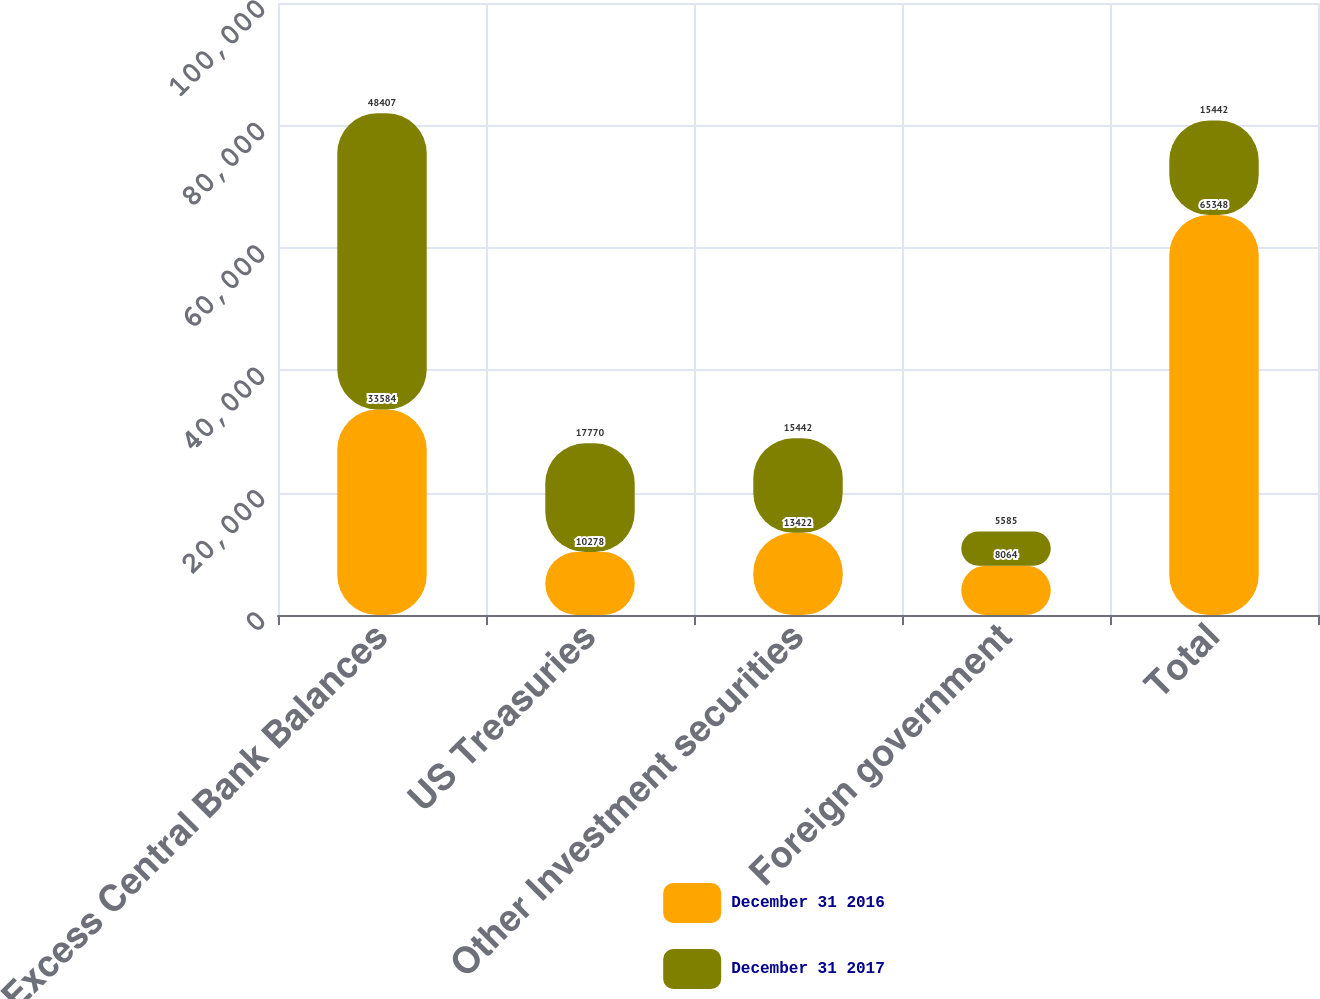<chart> <loc_0><loc_0><loc_500><loc_500><stacked_bar_chart><ecel><fcel>Excess Central Bank Balances<fcel>US Treasuries<fcel>Other Investment securities<fcel>Foreign government<fcel>Total<nl><fcel>December 31 2016<fcel>33584<fcel>10278<fcel>13422<fcel>8064<fcel>65348<nl><fcel>December 31 2017<fcel>48407<fcel>17770<fcel>15442<fcel>5585<fcel>15442<nl></chart> 